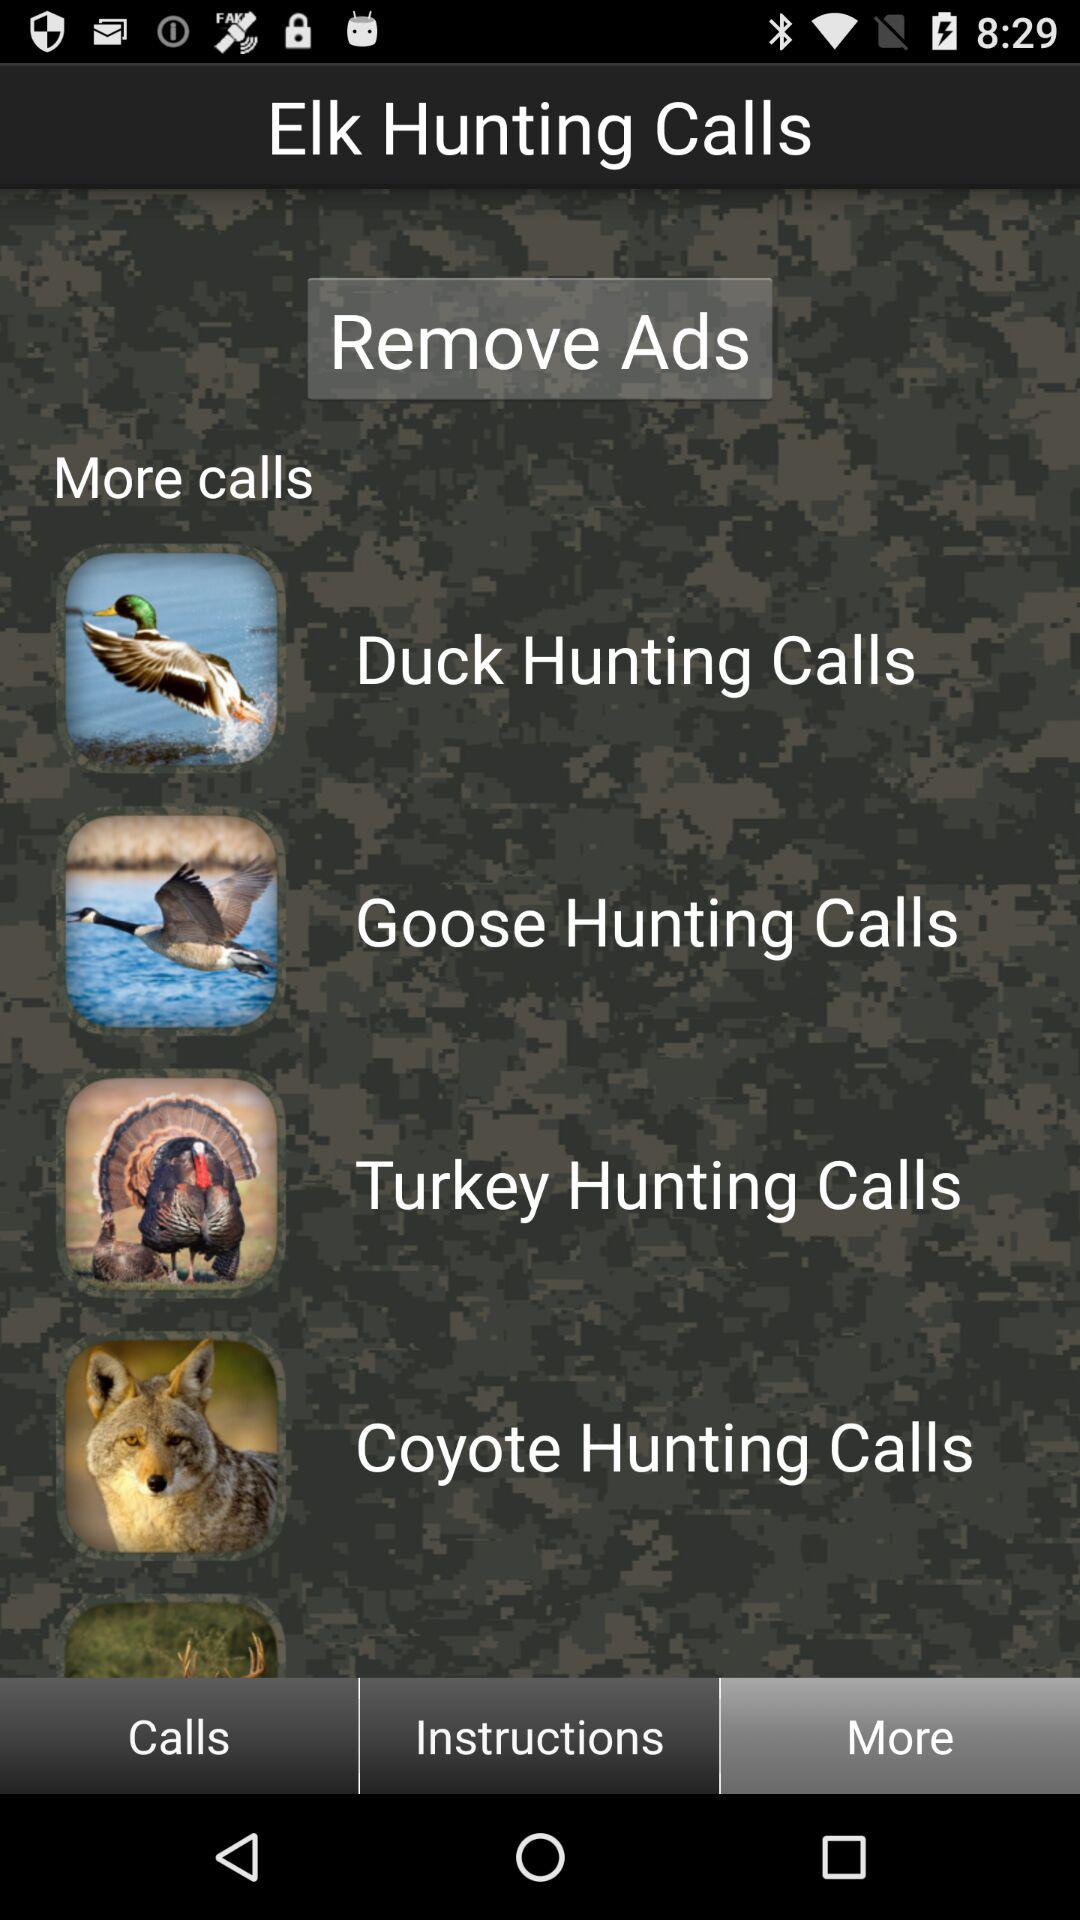Which tab is currently selected? The selected tab is "More". 